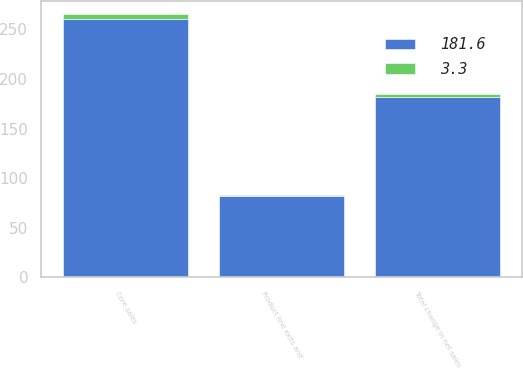Convert chart. <chart><loc_0><loc_0><loc_500><loc_500><stacked_bar_chart><ecel><fcel>Core sales<fcel>Product line exits and<fcel>Total change in net sales<nl><fcel>181.6<fcel>261.1<fcel>81.7<fcel>181.6<nl><fcel>3.3<fcel>4.7<fcel>1.4<fcel>3.3<nl></chart> 